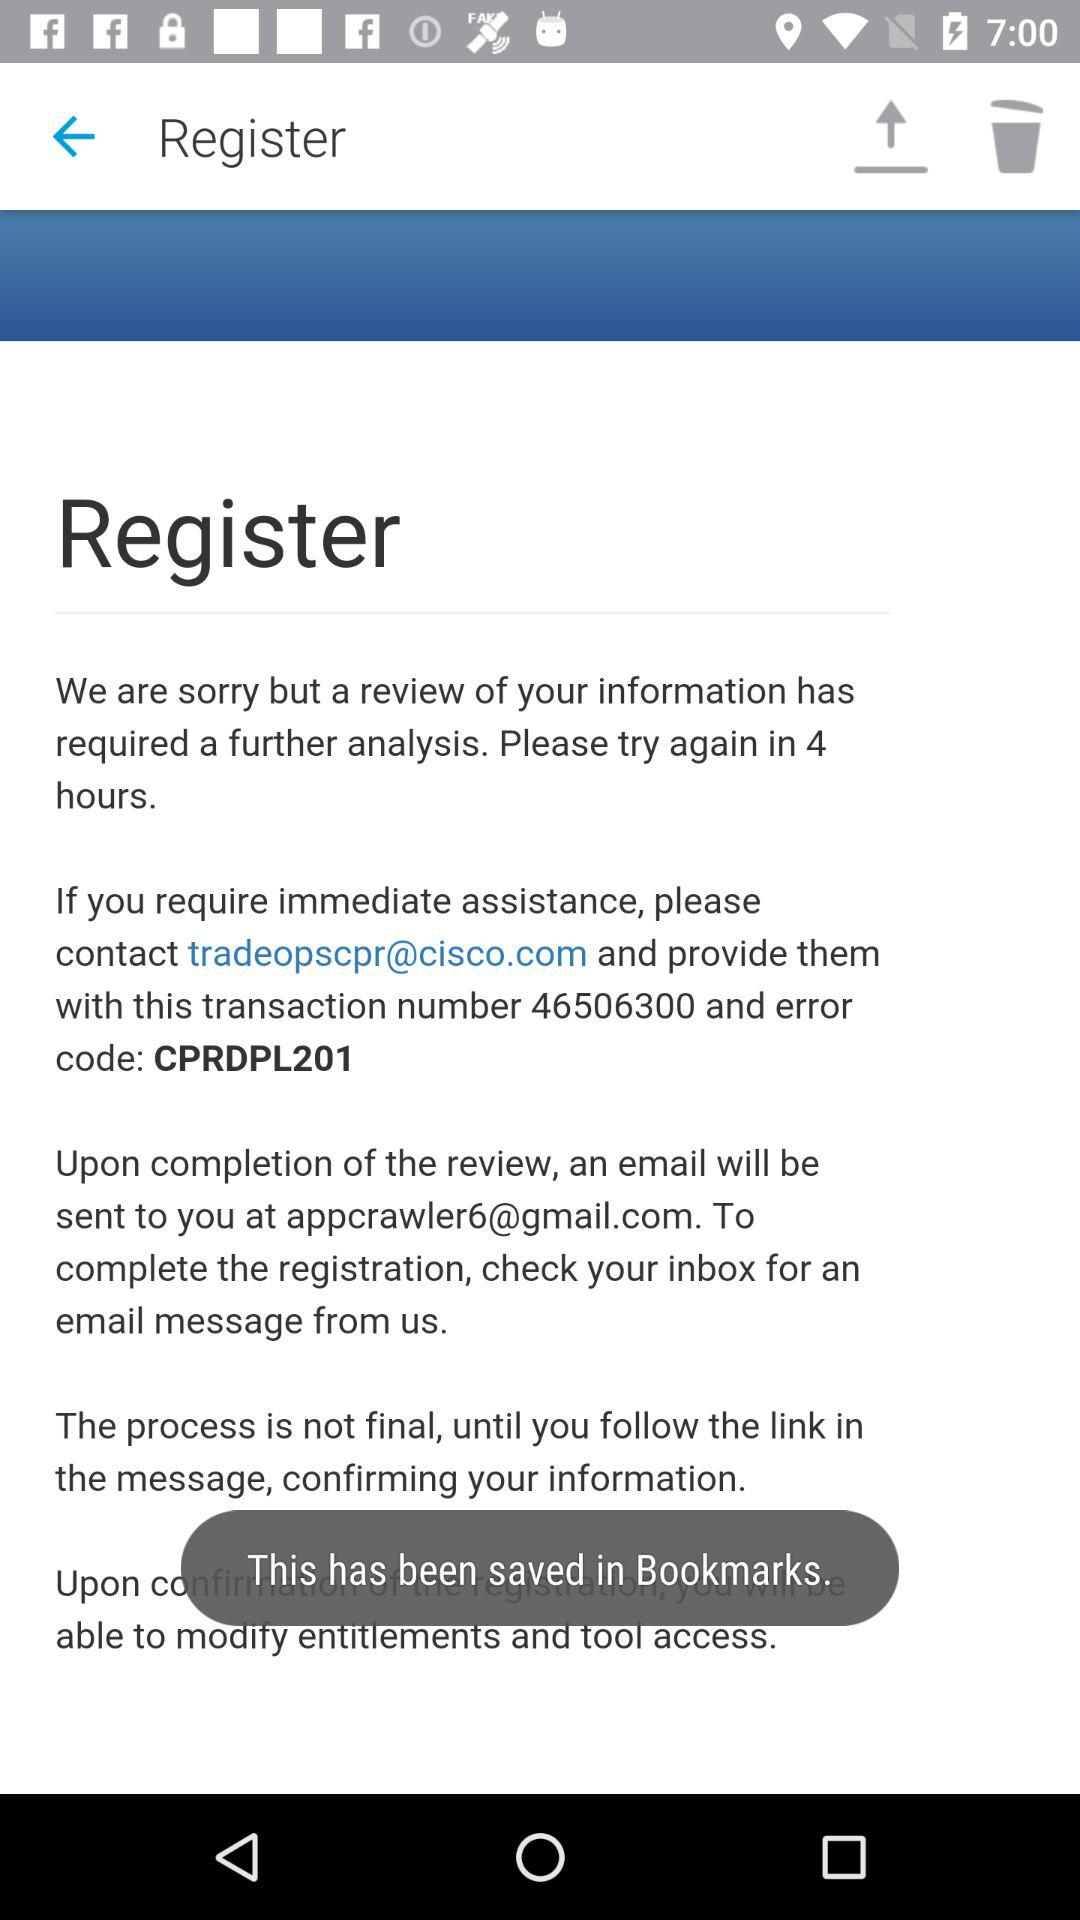After how many hours do we have to try again? You have to try again after 4 hours. 